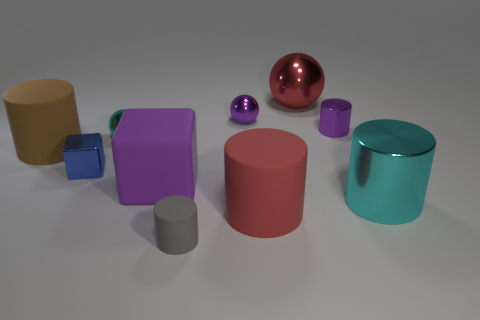Is the color of the large matte block the same as the tiny shiny cylinder?
Provide a short and direct response. Yes. Are there the same number of balls left of the brown cylinder and large cyan matte cubes?
Your response must be concise. Yes. What number of cylinders are both to the left of the purple shiny cylinder and in front of the big purple cube?
Ensure brevity in your answer.  2. There is a gray matte object that is the same shape as the big cyan thing; what size is it?
Your answer should be compact. Small. What number of cyan objects are the same material as the small blue block?
Your answer should be very brief. 2. Are there fewer tiny purple metallic balls that are in front of the purple shiny cylinder than purple blocks?
Provide a succinct answer. Yes. How many gray objects are there?
Your answer should be very brief. 1. What number of small balls have the same color as the tiny metal cube?
Give a very brief answer. 0. Is the shape of the large brown rubber object the same as the red rubber object?
Ensure brevity in your answer.  Yes. There is a red object in front of the matte cylinder on the left side of the large purple matte block; how big is it?
Your answer should be compact. Large. 